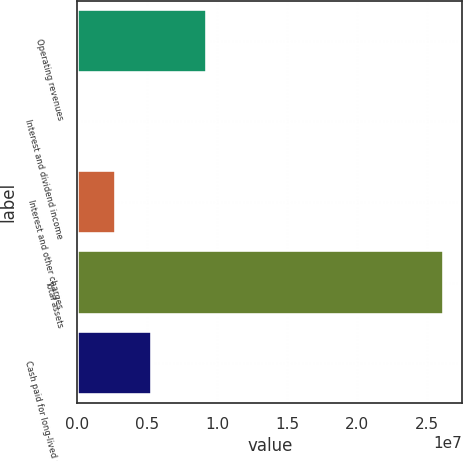Convert chart. <chart><loc_0><loc_0><loc_500><loc_500><bar_chart><fcel>Operating revenues<fcel>Interest and dividend income<fcel>Interest and other charges<fcel>Total assets<fcel>Cash paid for long-lived asset<nl><fcel>9.25508e+06<fcel>124992<fcel>2.72991e+06<fcel>2.61742e+07<fcel>5.33483e+06<nl></chart> 